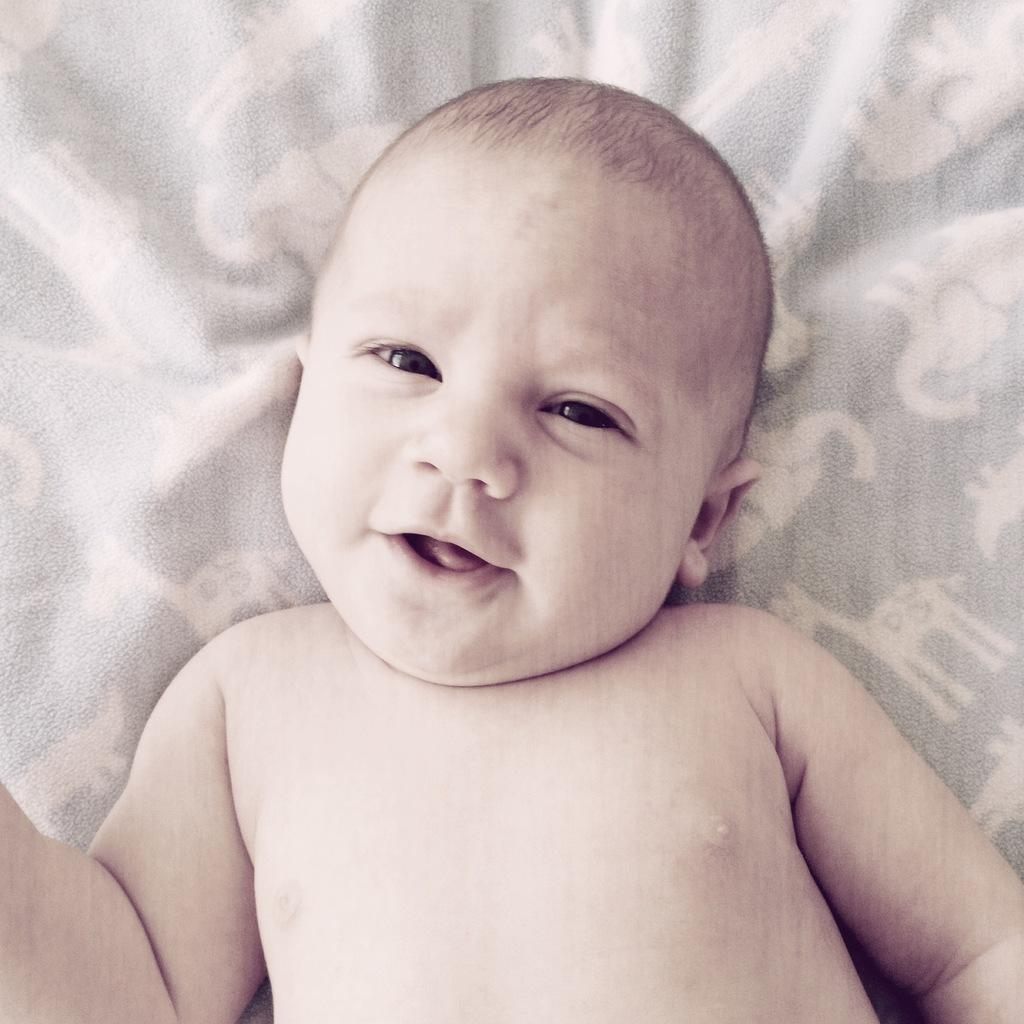What is the main subject of the image? There is a baby in the image. What is the baby doing in the image? The baby is smiling. What can be seen in the background of the image? There is a cloth visible in the background of the image. How many planes are flying in the background of the image? There are no planes visible in the background of the image. What type of hair does the baby have in the image? The image does not show the baby's hair, so it cannot be determined from the image. 